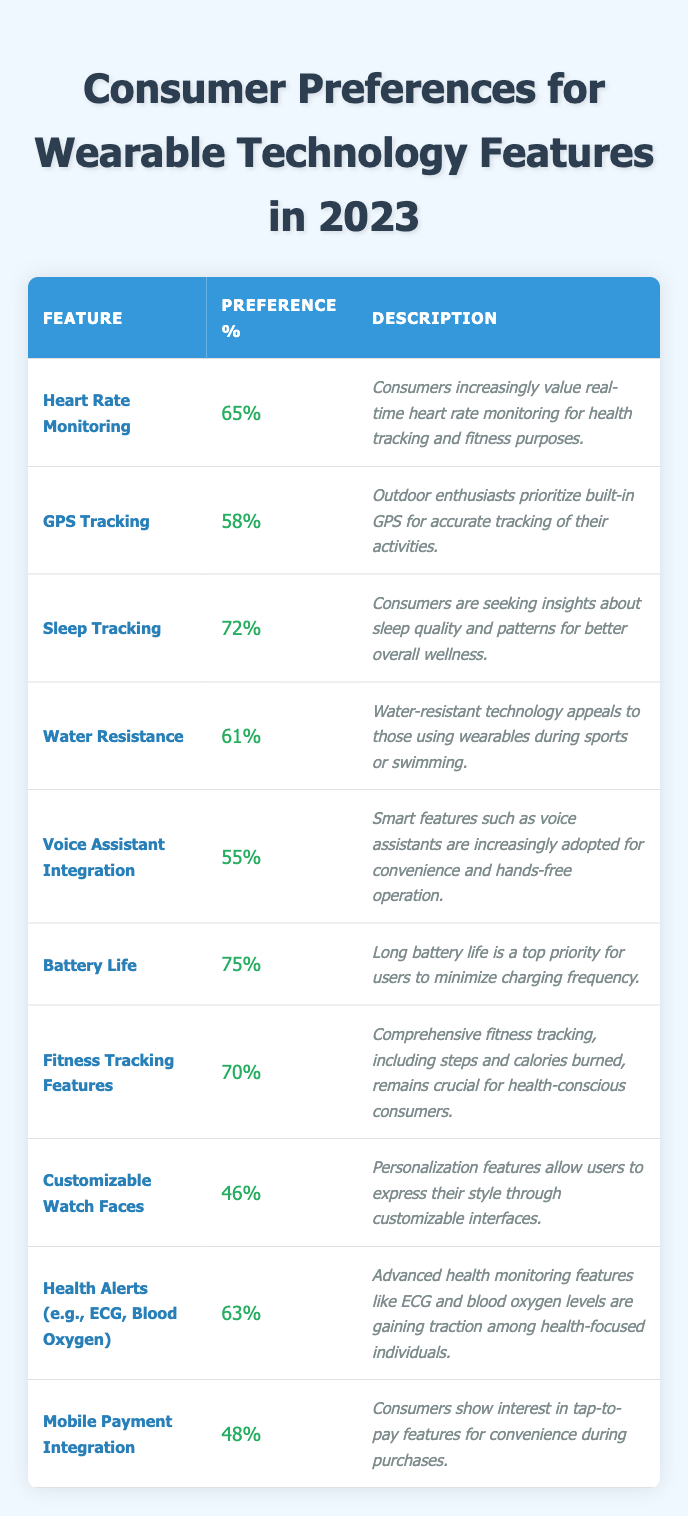What is the most preferred wearable technology feature according to the table? The table shows that "Battery Life" has the highest preference percentage at 75%.
Answer: Battery Life How many features have a preference percentage above 60%? From the table, the features with percentages above 60% are: Heart Rate Monitoring (65%), Sleep Tracking (72%), Water Resistance (61%), Fitness Tracking Features (70%), Health Alerts (63%), totaling 5 features.
Answer: 5 What is the preference percentage for "Customizable Watch Faces"? The table indicates that "Customizable Watch Faces" has a preference percentage of 46%.
Answer: 46% Is "Mobile Payment Integration" among the top three features in terms of preference percentage? The top three features based on preference are Battery Life (75%), Sleep Tracking (72%), and Fitness Tracking Features (70%). Since Mobile Payment Integration (48%) is not in this list, the answer is no.
Answer: No Which feature has a lower preference percentage: GPS Tracking or Voice Assistant Integration? GPS Tracking has a preference percentage of 58%, while Voice Assistant Integration has 55%. Since 55% is less than 58%, Voice Assistant Integration is the lower.
Answer: Voice Assistant Integration What is the combined preference percentage of features related to health monitoring? The features related to health monitoring are Heart Rate Monitoring (65%), Sleep Tracking (72%), Health Alerts (63%). Their combined preference is 65 + 72 + 63 = 200.
Answer: 200 What feature has a preference percentage the closest to the average of all the features? First, sum all the percentages: 65 + 58 + 72 + 61 + 55 + 75 + 70 + 46 + 63 + 48 =  619. There are 10 features, so the average is 619/10 = 61.9. The closest feature is Water Resistance with 61%.
Answer: Water Resistance Are consumers more interested in fitness tracking or mobile payment integration? Fitness tracking has a preference percentage of 70%, while mobile payment integration has 48%, making it clear that interest in fitness tracking is significantly higher.
Answer: Fitness tracking What is the percentage difference between Battery Life and Customizable Watch Faces? The preference for Battery Life is 75%, while Customizable Watch Faces is at 46%. The difference is 75 - 46 = 29%.
Answer: 29% Which feature has the lowest preference percentage, and what is it? The feature with the lowest percentage in the table is Customizable Watch Faces, at 46%.
Answer: Customizable Watch Faces 